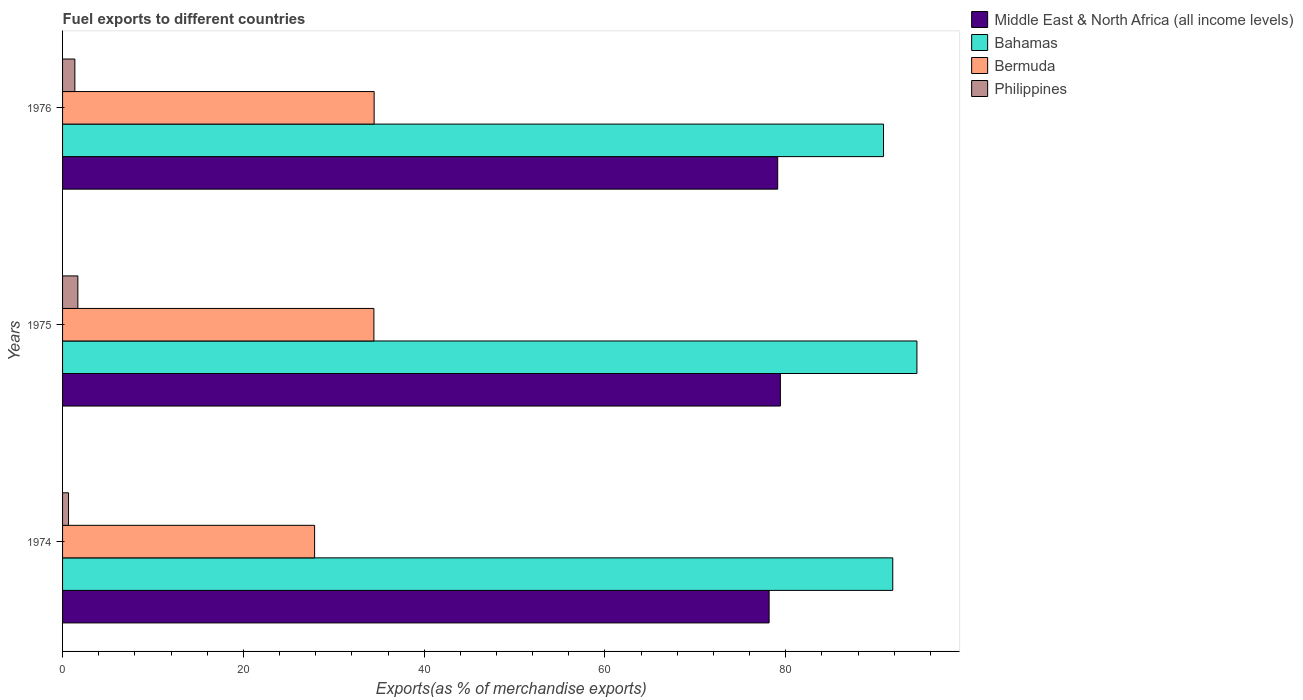How many different coloured bars are there?
Keep it short and to the point. 4. Are the number of bars per tick equal to the number of legend labels?
Your answer should be compact. Yes. What is the label of the 1st group of bars from the top?
Ensure brevity in your answer.  1976. In how many cases, is the number of bars for a given year not equal to the number of legend labels?
Give a very brief answer. 0. What is the percentage of exports to different countries in Bermuda in 1975?
Offer a terse response. 34.44. Across all years, what is the maximum percentage of exports to different countries in Philippines?
Give a very brief answer. 1.69. Across all years, what is the minimum percentage of exports to different countries in Bahamas?
Offer a very short reply. 90.81. In which year was the percentage of exports to different countries in Bahamas maximum?
Offer a very short reply. 1975. In which year was the percentage of exports to different countries in Middle East & North Africa (all income levels) minimum?
Keep it short and to the point. 1974. What is the total percentage of exports to different countries in Philippines in the graph?
Give a very brief answer. 3.71. What is the difference between the percentage of exports to different countries in Philippines in 1975 and that in 1976?
Your answer should be very brief. 0.33. What is the difference between the percentage of exports to different countries in Bahamas in 1975 and the percentage of exports to different countries in Philippines in 1974?
Provide a succinct answer. 93.85. What is the average percentage of exports to different countries in Bermuda per year?
Your answer should be very brief. 32.26. In the year 1975, what is the difference between the percentage of exports to different countries in Bahamas and percentage of exports to different countries in Middle East & North Africa (all income levels)?
Make the answer very short. 15.1. What is the ratio of the percentage of exports to different countries in Bahamas in 1974 to that in 1976?
Your answer should be compact. 1.01. Is the difference between the percentage of exports to different countries in Bahamas in 1974 and 1975 greater than the difference between the percentage of exports to different countries in Middle East & North Africa (all income levels) in 1974 and 1975?
Provide a short and direct response. No. What is the difference between the highest and the second highest percentage of exports to different countries in Middle East & North Africa (all income levels)?
Your answer should be compact. 0.3. What is the difference between the highest and the lowest percentage of exports to different countries in Philippines?
Make the answer very short. 1.03. Is the sum of the percentage of exports to different countries in Middle East & North Africa (all income levels) in 1975 and 1976 greater than the maximum percentage of exports to different countries in Philippines across all years?
Your answer should be very brief. Yes. Is it the case that in every year, the sum of the percentage of exports to different countries in Bahamas and percentage of exports to different countries in Middle East & North Africa (all income levels) is greater than the sum of percentage of exports to different countries in Bermuda and percentage of exports to different countries in Philippines?
Your response must be concise. Yes. What does the 4th bar from the top in 1975 represents?
Your response must be concise. Middle East & North Africa (all income levels). What does the 1st bar from the bottom in 1976 represents?
Provide a succinct answer. Middle East & North Africa (all income levels). Is it the case that in every year, the sum of the percentage of exports to different countries in Bahamas and percentage of exports to different countries in Middle East & North Africa (all income levels) is greater than the percentage of exports to different countries in Bermuda?
Ensure brevity in your answer.  Yes. What is the difference between two consecutive major ticks on the X-axis?
Offer a very short reply. 20. Are the values on the major ticks of X-axis written in scientific E-notation?
Offer a very short reply. No. Does the graph contain any zero values?
Provide a short and direct response. No. Does the graph contain grids?
Your answer should be compact. No. How many legend labels are there?
Keep it short and to the point. 4. What is the title of the graph?
Ensure brevity in your answer.  Fuel exports to different countries. What is the label or title of the X-axis?
Offer a very short reply. Exports(as % of merchandise exports). What is the label or title of the Y-axis?
Your answer should be compact. Years. What is the Exports(as % of merchandise exports) in Middle East & North Africa (all income levels) in 1974?
Make the answer very short. 78.16. What is the Exports(as % of merchandise exports) in Bahamas in 1974?
Your answer should be very brief. 91.84. What is the Exports(as % of merchandise exports) in Bermuda in 1974?
Offer a terse response. 27.88. What is the Exports(as % of merchandise exports) of Philippines in 1974?
Ensure brevity in your answer.  0.66. What is the Exports(as % of merchandise exports) in Middle East & North Africa (all income levels) in 1975?
Keep it short and to the point. 79.41. What is the Exports(as % of merchandise exports) in Bahamas in 1975?
Keep it short and to the point. 94.51. What is the Exports(as % of merchandise exports) of Bermuda in 1975?
Your response must be concise. 34.44. What is the Exports(as % of merchandise exports) in Philippines in 1975?
Offer a very short reply. 1.69. What is the Exports(as % of merchandise exports) of Middle East & North Africa (all income levels) in 1976?
Provide a short and direct response. 79.11. What is the Exports(as % of merchandise exports) of Bahamas in 1976?
Make the answer very short. 90.81. What is the Exports(as % of merchandise exports) in Bermuda in 1976?
Make the answer very short. 34.47. What is the Exports(as % of merchandise exports) of Philippines in 1976?
Offer a very short reply. 1.36. Across all years, what is the maximum Exports(as % of merchandise exports) in Middle East & North Africa (all income levels)?
Keep it short and to the point. 79.41. Across all years, what is the maximum Exports(as % of merchandise exports) of Bahamas?
Your answer should be compact. 94.51. Across all years, what is the maximum Exports(as % of merchandise exports) of Bermuda?
Provide a succinct answer. 34.47. Across all years, what is the maximum Exports(as % of merchandise exports) in Philippines?
Your answer should be compact. 1.69. Across all years, what is the minimum Exports(as % of merchandise exports) of Middle East & North Africa (all income levels)?
Your answer should be very brief. 78.16. Across all years, what is the minimum Exports(as % of merchandise exports) of Bahamas?
Your answer should be compact. 90.81. Across all years, what is the minimum Exports(as % of merchandise exports) of Bermuda?
Your response must be concise. 27.88. Across all years, what is the minimum Exports(as % of merchandise exports) in Philippines?
Give a very brief answer. 0.66. What is the total Exports(as % of merchandise exports) in Middle East & North Africa (all income levels) in the graph?
Your response must be concise. 236.67. What is the total Exports(as % of merchandise exports) of Bahamas in the graph?
Ensure brevity in your answer.  277.16. What is the total Exports(as % of merchandise exports) of Bermuda in the graph?
Ensure brevity in your answer.  96.79. What is the total Exports(as % of merchandise exports) of Philippines in the graph?
Your answer should be compact. 3.71. What is the difference between the Exports(as % of merchandise exports) of Middle East & North Africa (all income levels) in 1974 and that in 1975?
Your answer should be very brief. -1.25. What is the difference between the Exports(as % of merchandise exports) of Bahamas in 1974 and that in 1975?
Keep it short and to the point. -2.67. What is the difference between the Exports(as % of merchandise exports) of Bermuda in 1974 and that in 1975?
Give a very brief answer. -6.56. What is the difference between the Exports(as % of merchandise exports) of Philippines in 1974 and that in 1975?
Your answer should be very brief. -1.03. What is the difference between the Exports(as % of merchandise exports) of Middle East & North Africa (all income levels) in 1974 and that in 1976?
Your response must be concise. -0.95. What is the difference between the Exports(as % of merchandise exports) of Bahamas in 1974 and that in 1976?
Keep it short and to the point. 1.02. What is the difference between the Exports(as % of merchandise exports) of Bermuda in 1974 and that in 1976?
Offer a terse response. -6.59. What is the difference between the Exports(as % of merchandise exports) in Philippines in 1974 and that in 1976?
Ensure brevity in your answer.  -0.7. What is the difference between the Exports(as % of merchandise exports) of Middle East & North Africa (all income levels) in 1975 and that in 1976?
Keep it short and to the point. 0.3. What is the difference between the Exports(as % of merchandise exports) in Bahamas in 1975 and that in 1976?
Provide a short and direct response. 3.7. What is the difference between the Exports(as % of merchandise exports) of Bermuda in 1975 and that in 1976?
Offer a very short reply. -0.03. What is the difference between the Exports(as % of merchandise exports) in Philippines in 1975 and that in 1976?
Offer a very short reply. 0.33. What is the difference between the Exports(as % of merchandise exports) of Middle East & North Africa (all income levels) in 1974 and the Exports(as % of merchandise exports) of Bahamas in 1975?
Your answer should be compact. -16.35. What is the difference between the Exports(as % of merchandise exports) in Middle East & North Africa (all income levels) in 1974 and the Exports(as % of merchandise exports) in Bermuda in 1975?
Your answer should be very brief. 43.72. What is the difference between the Exports(as % of merchandise exports) of Middle East & North Africa (all income levels) in 1974 and the Exports(as % of merchandise exports) of Philippines in 1975?
Your answer should be very brief. 76.47. What is the difference between the Exports(as % of merchandise exports) in Bahamas in 1974 and the Exports(as % of merchandise exports) in Bermuda in 1975?
Make the answer very short. 57.4. What is the difference between the Exports(as % of merchandise exports) of Bahamas in 1974 and the Exports(as % of merchandise exports) of Philippines in 1975?
Provide a succinct answer. 90.14. What is the difference between the Exports(as % of merchandise exports) of Bermuda in 1974 and the Exports(as % of merchandise exports) of Philippines in 1975?
Provide a short and direct response. 26.19. What is the difference between the Exports(as % of merchandise exports) of Middle East & North Africa (all income levels) in 1974 and the Exports(as % of merchandise exports) of Bahamas in 1976?
Provide a succinct answer. -12.65. What is the difference between the Exports(as % of merchandise exports) of Middle East & North Africa (all income levels) in 1974 and the Exports(as % of merchandise exports) of Bermuda in 1976?
Offer a terse response. 43.69. What is the difference between the Exports(as % of merchandise exports) in Middle East & North Africa (all income levels) in 1974 and the Exports(as % of merchandise exports) in Philippines in 1976?
Your response must be concise. 76.8. What is the difference between the Exports(as % of merchandise exports) of Bahamas in 1974 and the Exports(as % of merchandise exports) of Bermuda in 1976?
Ensure brevity in your answer.  57.37. What is the difference between the Exports(as % of merchandise exports) of Bahamas in 1974 and the Exports(as % of merchandise exports) of Philippines in 1976?
Keep it short and to the point. 90.48. What is the difference between the Exports(as % of merchandise exports) of Bermuda in 1974 and the Exports(as % of merchandise exports) of Philippines in 1976?
Make the answer very short. 26.52. What is the difference between the Exports(as % of merchandise exports) in Middle East & North Africa (all income levels) in 1975 and the Exports(as % of merchandise exports) in Bahamas in 1976?
Provide a short and direct response. -11.41. What is the difference between the Exports(as % of merchandise exports) in Middle East & North Africa (all income levels) in 1975 and the Exports(as % of merchandise exports) in Bermuda in 1976?
Make the answer very short. 44.94. What is the difference between the Exports(as % of merchandise exports) in Middle East & North Africa (all income levels) in 1975 and the Exports(as % of merchandise exports) in Philippines in 1976?
Your response must be concise. 78.04. What is the difference between the Exports(as % of merchandise exports) of Bahamas in 1975 and the Exports(as % of merchandise exports) of Bermuda in 1976?
Keep it short and to the point. 60.04. What is the difference between the Exports(as % of merchandise exports) of Bahamas in 1975 and the Exports(as % of merchandise exports) of Philippines in 1976?
Offer a very short reply. 93.15. What is the difference between the Exports(as % of merchandise exports) in Bermuda in 1975 and the Exports(as % of merchandise exports) in Philippines in 1976?
Offer a very short reply. 33.08. What is the average Exports(as % of merchandise exports) in Middle East & North Africa (all income levels) per year?
Your answer should be compact. 78.89. What is the average Exports(as % of merchandise exports) of Bahamas per year?
Keep it short and to the point. 92.39. What is the average Exports(as % of merchandise exports) in Bermuda per year?
Your answer should be very brief. 32.26. What is the average Exports(as % of merchandise exports) of Philippines per year?
Offer a very short reply. 1.24. In the year 1974, what is the difference between the Exports(as % of merchandise exports) of Middle East & North Africa (all income levels) and Exports(as % of merchandise exports) of Bahamas?
Your answer should be very brief. -13.68. In the year 1974, what is the difference between the Exports(as % of merchandise exports) of Middle East & North Africa (all income levels) and Exports(as % of merchandise exports) of Bermuda?
Offer a very short reply. 50.28. In the year 1974, what is the difference between the Exports(as % of merchandise exports) in Middle East & North Africa (all income levels) and Exports(as % of merchandise exports) in Philippines?
Make the answer very short. 77.5. In the year 1974, what is the difference between the Exports(as % of merchandise exports) in Bahamas and Exports(as % of merchandise exports) in Bermuda?
Keep it short and to the point. 63.96. In the year 1974, what is the difference between the Exports(as % of merchandise exports) in Bahamas and Exports(as % of merchandise exports) in Philippines?
Your answer should be compact. 91.18. In the year 1974, what is the difference between the Exports(as % of merchandise exports) in Bermuda and Exports(as % of merchandise exports) in Philippines?
Make the answer very short. 27.22. In the year 1975, what is the difference between the Exports(as % of merchandise exports) in Middle East & North Africa (all income levels) and Exports(as % of merchandise exports) in Bahamas?
Your response must be concise. -15.1. In the year 1975, what is the difference between the Exports(as % of merchandise exports) in Middle East & North Africa (all income levels) and Exports(as % of merchandise exports) in Bermuda?
Offer a terse response. 44.97. In the year 1975, what is the difference between the Exports(as % of merchandise exports) in Middle East & North Africa (all income levels) and Exports(as % of merchandise exports) in Philippines?
Keep it short and to the point. 77.71. In the year 1975, what is the difference between the Exports(as % of merchandise exports) in Bahamas and Exports(as % of merchandise exports) in Bermuda?
Make the answer very short. 60.07. In the year 1975, what is the difference between the Exports(as % of merchandise exports) of Bahamas and Exports(as % of merchandise exports) of Philippines?
Offer a terse response. 92.82. In the year 1975, what is the difference between the Exports(as % of merchandise exports) of Bermuda and Exports(as % of merchandise exports) of Philippines?
Provide a succinct answer. 32.75. In the year 1976, what is the difference between the Exports(as % of merchandise exports) of Middle East & North Africa (all income levels) and Exports(as % of merchandise exports) of Bahamas?
Offer a very short reply. -11.71. In the year 1976, what is the difference between the Exports(as % of merchandise exports) in Middle East & North Africa (all income levels) and Exports(as % of merchandise exports) in Bermuda?
Keep it short and to the point. 44.64. In the year 1976, what is the difference between the Exports(as % of merchandise exports) of Middle East & North Africa (all income levels) and Exports(as % of merchandise exports) of Philippines?
Keep it short and to the point. 77.75. In the year 1976, what is the difference between the Exports(as % of merchandise exports) in Bahamas and Exports(as % of merchandise exports) in Bermuda?
Your answer should be very brief. 56.35. In the year 1976, what is the difference between the Exports(as % of merchandise exports) in Bahamas and Exports(as % of merchandise exports) in Philippines?
Your answer should be compact. 89.45. In the year 1976, what is the difference between the Exports(as % of merchandise exports) in Bermuda and Exports(as % of merchandise exports) in Philippines?
Keep it short and to the point. 33.11. What is the ratio of the Exports(as % of merchandise exports) of Middle East & North Africa (all income levels) in 1974 to that in 1975?
Offer a terse response. 0.98. What is the ratio of the Exports(as % of merchandise exports) of Bahamas in 1974 to that in 1975?
Give a very brief answer. 0.97. What is the ratio of the Exports(as % of merchandise exports) of Bermuda in 1974 to that in 1975?
Provide a succinct answer. 0.81. What is the ratio of the Exports(as % of merchandise exports) in Philippines in 1974 to that in 1975?
Give a very brief answer. 0.39. What is the ratio of the Exports(as % of merchandise exports) of Bahamas in 1974 to that in 1976?
Your response must be concise. 1.01. What is the ratio of the Exports(as % of merchandise exports) in Bermuda in 1974 to that in 1976?
Your answer should be compact. 0.81. What is the ratio of the Exports(as % of merchandise exports) of Philippines in 1974 to that in 1976?
Your answer should be very brief. 0.48. What is the ratio of the Exports(as % of merchandise exports) in Bahamas in 1975 to that in 1976?
Make the answer very short. 1.04. What is the ratio of the Exports(as % of merchandise exports) in Bermuda in 1975 to that in 1976?
Offer a very short reply. 1. What is the ratio of the Exports(as % of merchandise exports) of Philippines in 1975 to that in 1976?
Offer a terse response. 1.24. What is the difference between the highest and the second highest Exports(as % of merchandise exports) in Middle East & North Africa (all income levels)?
Keep it short and to the point. 0.3. What is the difference between the highest and the second highest Exports(as % of merchandise exports) of Bahamas?
Make the answer very short. 2.67. What is the difference between the highest and the second highest Exports(as % of merchandise exports) in Bermuda?
Provide a short and direct response. 0.03. What is the difference between the highest and the second highest Exports(as % of merchandise exports) of Philippines?
Offer a terse response. 0.33. What is the difference between the highest and the lowest Exports(as % of merchandise exports) of Middle East & North Africa (all income levels)?
Ensure brevity in your answer.  1.25. What is the difference between the highest and the lowest Exports(as % of merchandise exports) of Bahamas?
Your answer should be compact. 3.7. What is the difference between the highest and the lowest Exports(as % of merchandise exports) of Bermuda?
Your response must be concise. 6.59. What is the difference between the highest and the lowest Exports(as % of merchandise exports) in Philippines?
Your response must be concise. 1.03. 